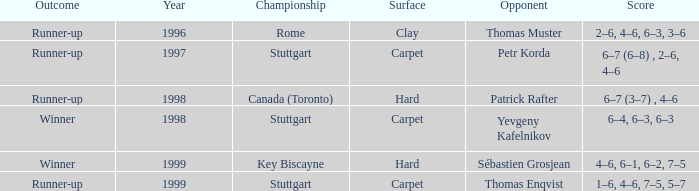Parse the full table. {'header': ['Outcome', 'Year', 'Championship', 'Surface', 'Opponent', 'Score'], 'rows': [['Runner-up', '1996', 'Rome', 'Clay', 'Thomas Muster', '2–6, 4–6, 6–3, 3–6'], ['Runner-up', '1997', 'Stuttgart', 'Carpet', 'Petr Korda', '6–7 (6–8) , 2–6, 4–6'], ['Runner-up', '1998', 'Canada (Toronto)', 'Hard', 'Patrick Rafter', '6–7 (3–7) , 4–6'], ['Winner', '1998', 'Stuttgart', 'Carpet', 'Yevgeny Kafelnikov', '6–4, 6–3, 6–3'], ['Winner', '1999', 'Key Biscayne', 'Hard', 'Sébastien Grosjean', '4–6, 6–1, 6–2, 7–5'], ['Runner-up', '1999', 'Stuttgart', 'Carpet', 'Thomas Enqvist', '1–6, 4–6, 7–5, 5–7']]} Which championship post-1997 had the score 1–6, 4–6, 7–5, 5–7? Stuttgart. 